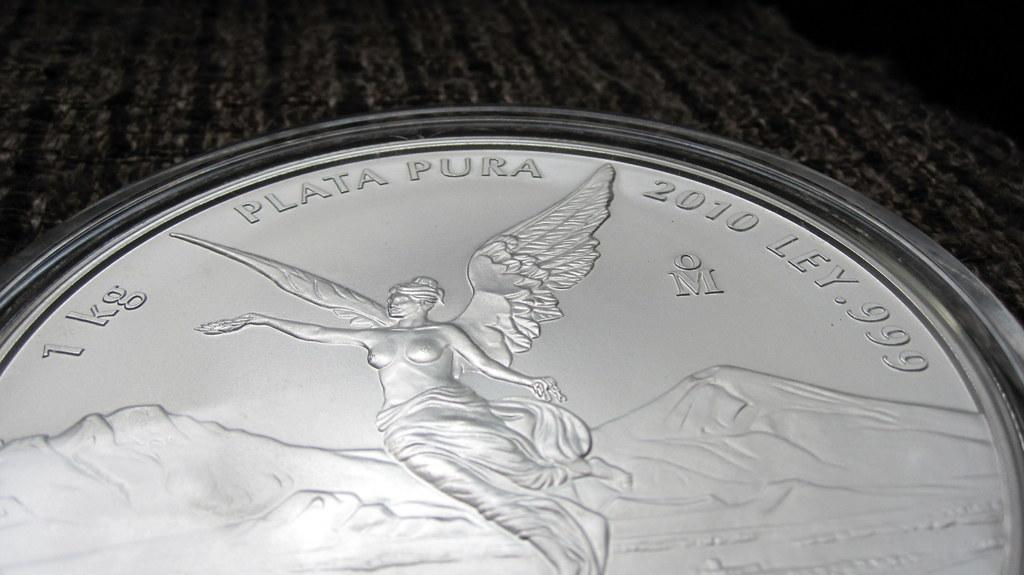<image>
Summarize the visual content of the image. A silver coin from 2010 says it weighs 1 kg. 